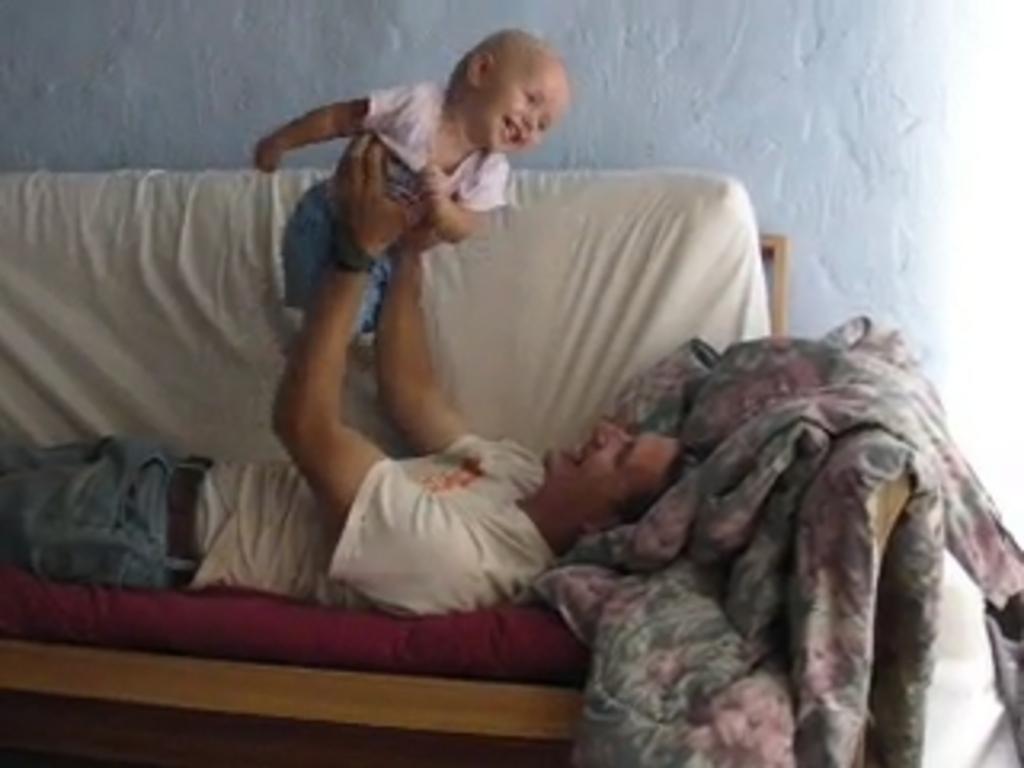Please provide a concise description of this image. This image is taken indoors. In the background there is a wall. In the middle of the image there is a couch with a blanket on it and there is a man on the couch and he is playing with a kid. 